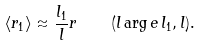<formula> <loc_0><loc_0><loc_500><loc_500>\langle { r } _ { 1 } \rangle \approx { \frac { l _ { 1 } } { l } } { r } \quad ( l \arg e \, l _ { 1 } , l ) .</formula> 